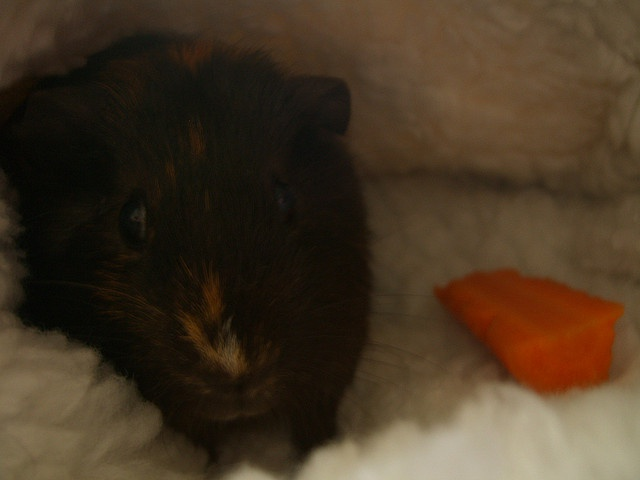Describe the objects in this image and their specific colors. I can see cat in black and maroon tones and carrot in maroon tones in this image. 